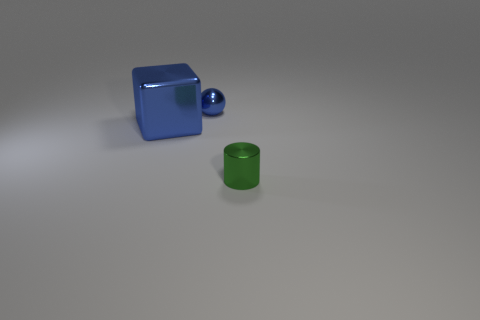What number of green objects have the same size as the cube?
Make the answer very short. 0. How many green objects are either small metal cylinders or tiny spheres?
Ensure brevity in your answer.  1. Is the number of tiny metallic spheres in front of the small green cylinder the same as the number of green matte balls?
Provide a short and direct response. Yes. How big is the object that is on the right side of the tiny blue metallic sphere?
Provide a short and direct response. Small. What number of other green objects are the same shape as the large metallic thing?
Offer a very short reply. 0. There is a object that is both in front of the tiny blue sphere and on the right side of the large blue shiny block; what is its material?
Make the answer very short. Metal. Are the large blue object and the blue ball made of the same material?
Your answer should be very brief. Yes. How many small blue things are there?
Provide a short and direct response. 1. The small object behind the tiny thing that is in front of the thing that is to the left of the sphere is what color?
Make the answer very short. Blue. Is the large block the same color as the sphere?
Give a very brief answer. Yes. 